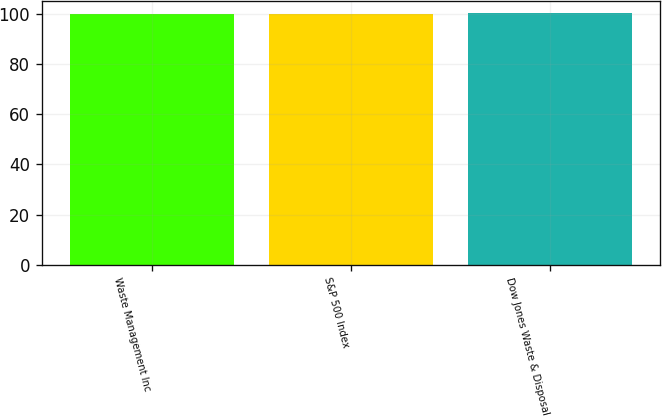<chart> <loc_0><loc_0><loc_500><loc_500><bar_chart><fcel>Waste Management Inc<fcel>S&P 500 Index<fcel>Dow Jones Waste & Disposal<nl><fcel>100<fcel>100.1<fcel>100.2<nl></chart> 